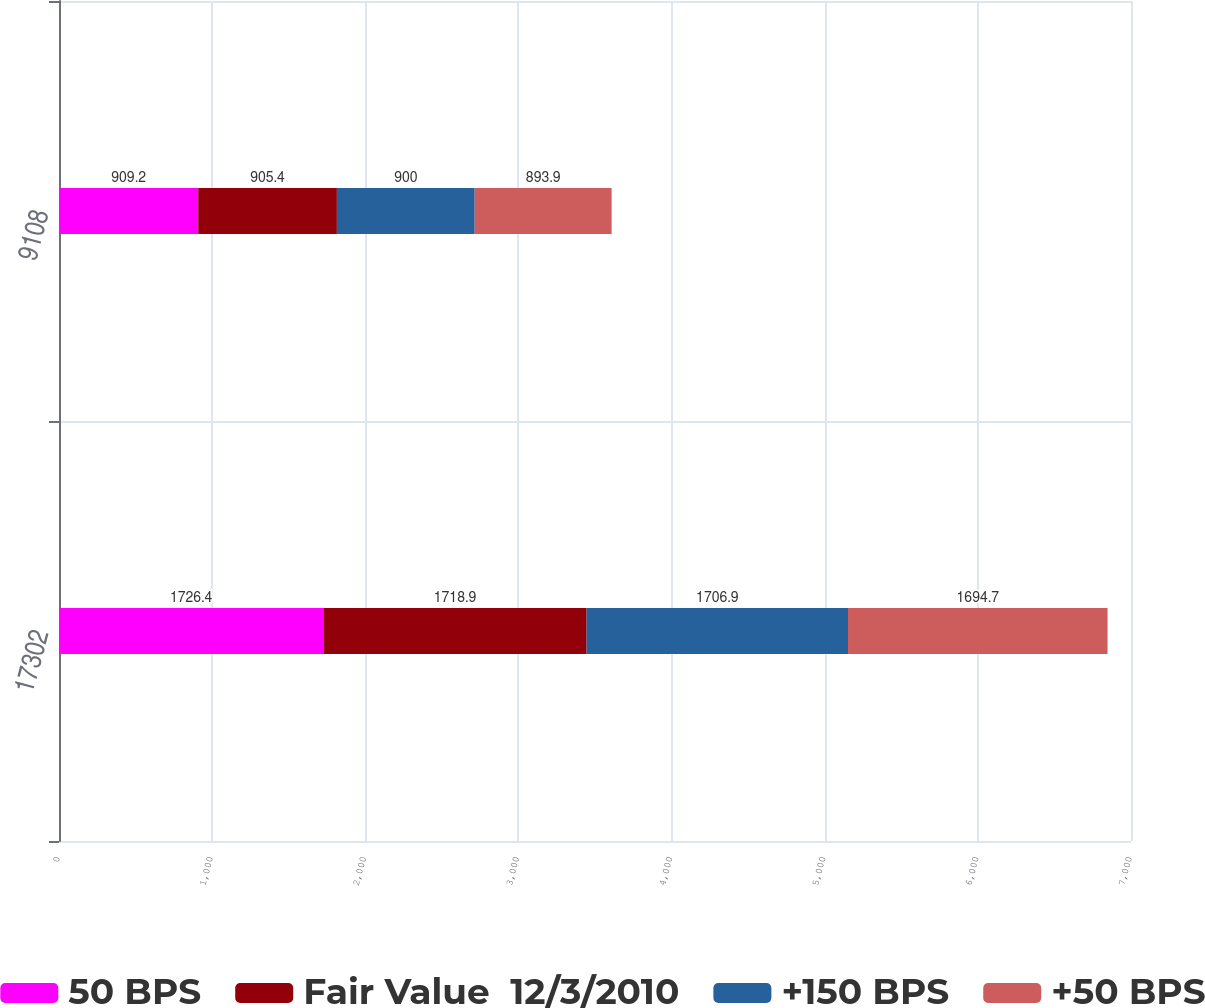<chart> <loc_0><loc_0><loc_500><loc_500><stacked_bar_chart><ecel><fcel>17302<fcel>9108<nl><fcel>50 BPS<fcel>1726.4<fcel>909.2<nl><fcel>Fair Value  12/3/2010<fcel>1718.9<fcel>905.4<nl><fcel>+150 BPS<fcel>1706.9<fcel>900<nl><fcel>+50 BPS<fcel>1694.7<fcel>893.9<nl></chart> 